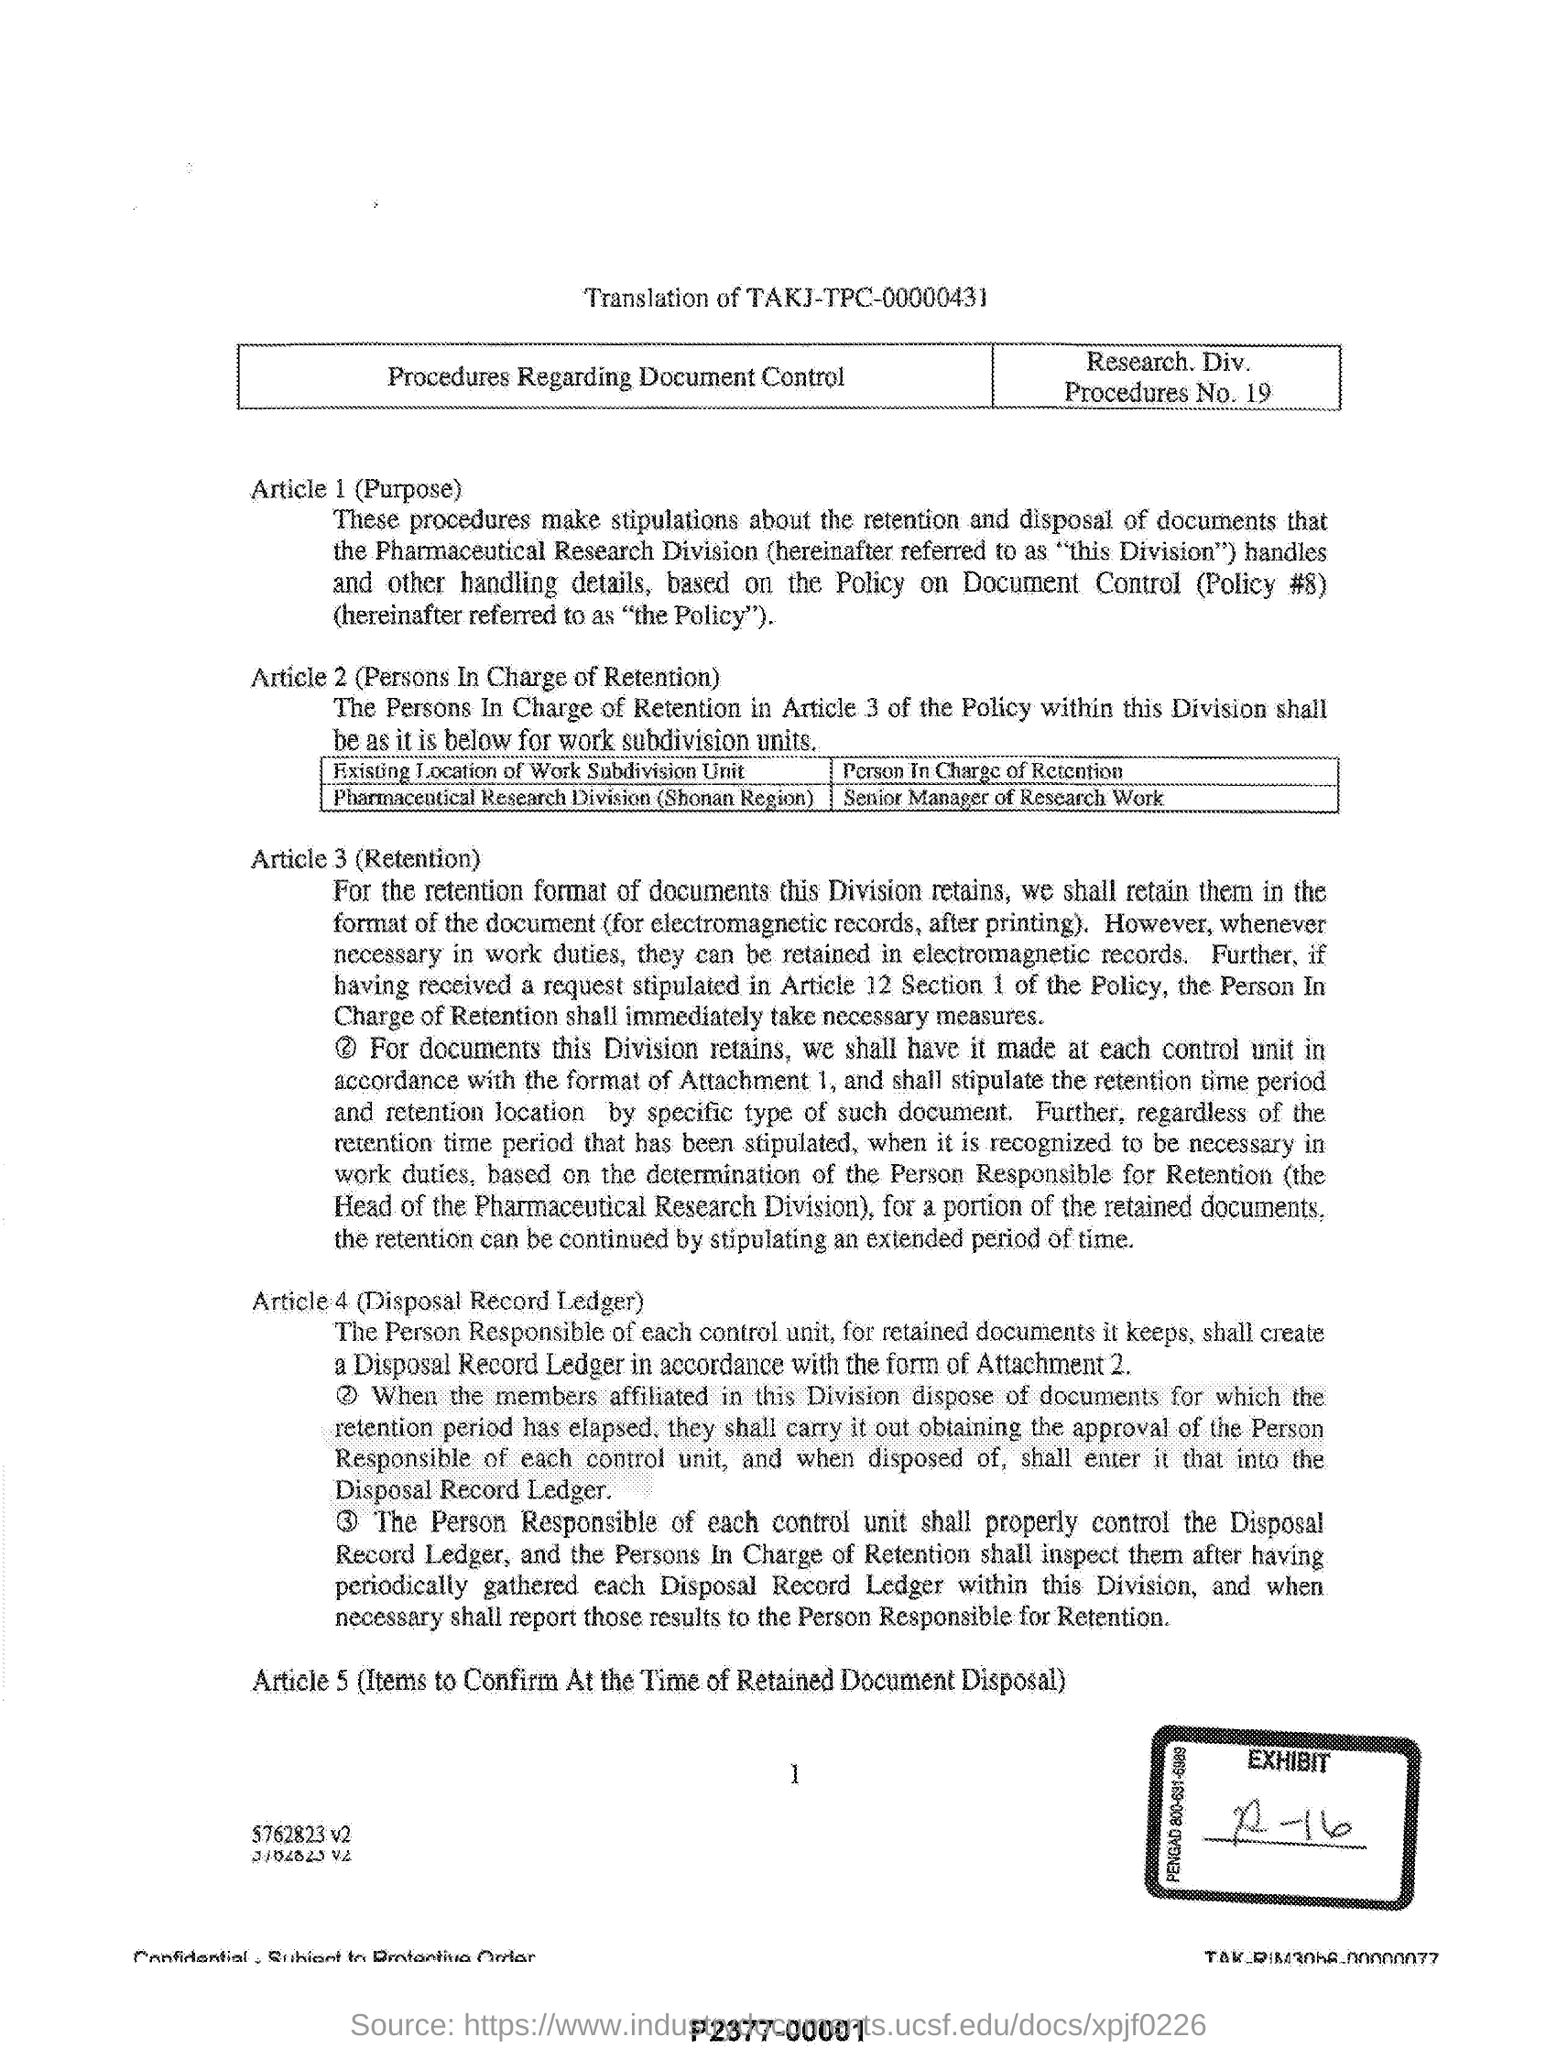Which Procedures No is being decribed here?
Offer a very short reply. Procedures No. 19. What is Article 4 in this document referred to?
Keep it short and to the point. Disposal Record Ledger. In which Article, Persons In Charge of Retention is described?
Offer a terse response. Article 2. 